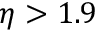Convert formula to latex. <formula><loc_0><loc_0><loc_500><loc_500>\eta > 1 . 9</formula> 